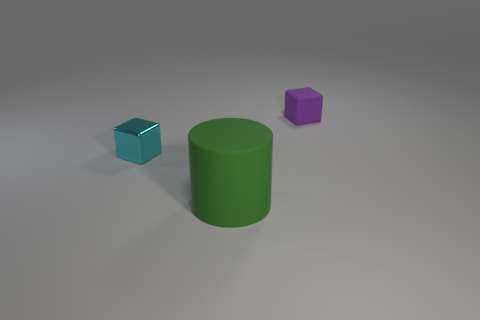There is a purple matte cube; is its size the same as the cube that is to the left of the big matte cylinder?
Ensure brevity in your answer.  Yes. There is a object behind the block that is in front of the rubber block; what number of small metallic blocks are on the left side of it?
Your response must be concise. 1. There is a green cylinder; are there any small cyan metallic things in front of it?
Your answer should be compact. No. What shape is the purple object?
Provide a succinct answer. Cube. What is the shape of the big green rubber object in front of the small block on the right side of the rubber object left of the purple cube?
Your answer should be compact. Cylinder. What number of other objects are there of the same shape as the small purple rubber object?
Your answer should be very brief. 1. What is the material of the tiny cube behind the cube that is in front of the small purple matte block?
Keep it short and to the point. Rubber. Is there anything else that has the same size as the cylinder?
Make the answer very short. No. Are the green cylinder and the small cube that is in front of the tiny purple matte thing made of the same material?
Your answer should be compact. No. The thing that is both on the right side of the tiny cyan metal block and in front of the purple cube is made of what material?
Provide a succinct answer. Rubber. 